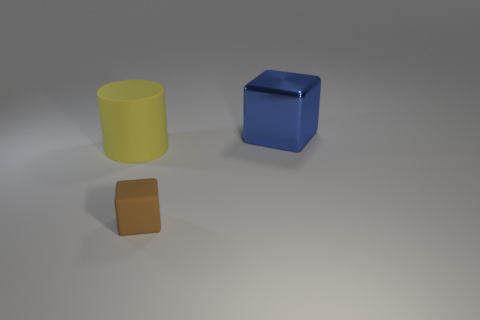Add 2 yellow rubber cylinders. How many objects exist? 5 Subtract all cylinders. How many objects are left? 2 Add 2 rubber cylinders. How many rubber cylinders are left? 3 Add 3 brown things. How many brown things exist? 4 Subtract 0 purple balls. How many objects are left? 3 Subtract all cubes. Subtract all blue metallic cubes. How many objects are left? 0 